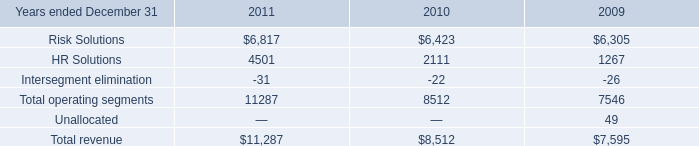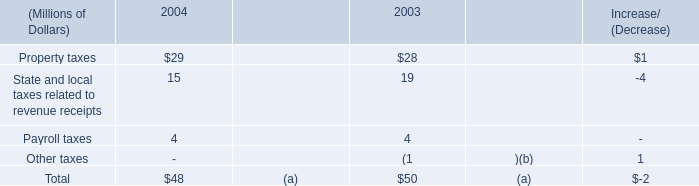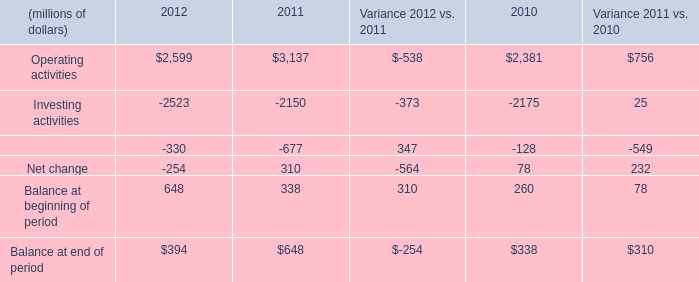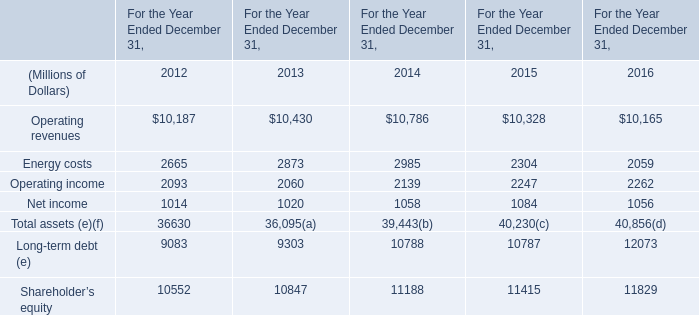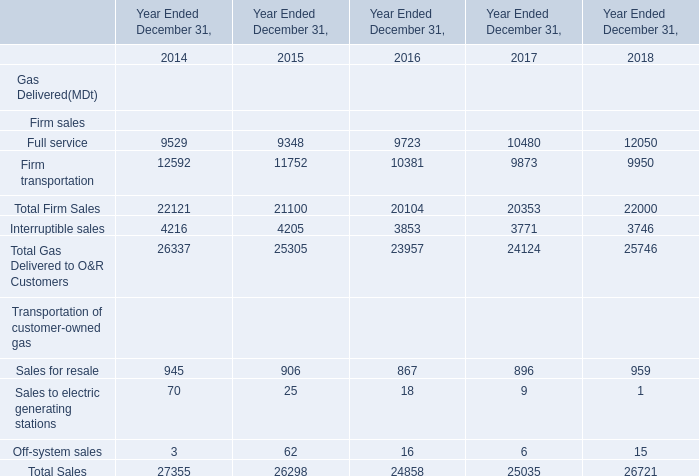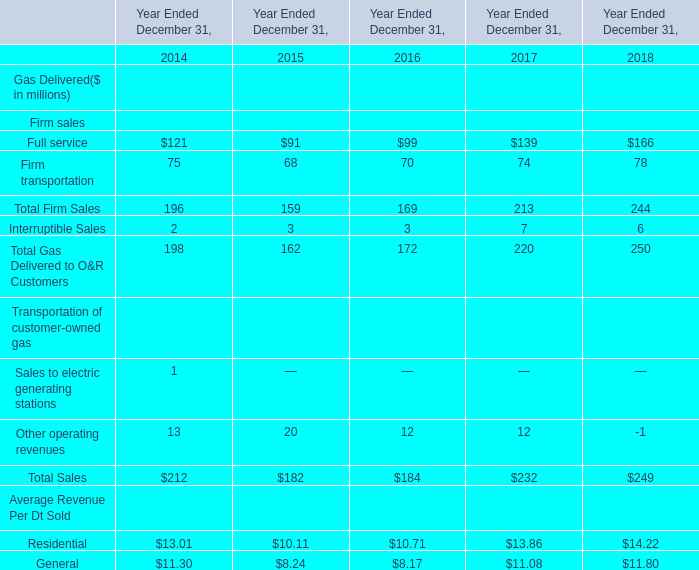What was the average value of Sales for resale, Sales to electric generating stations,Off-system sales in 2014 ? 
Computations: (((945 + 70) + 3) / 3)
Answer: 339.33333. 